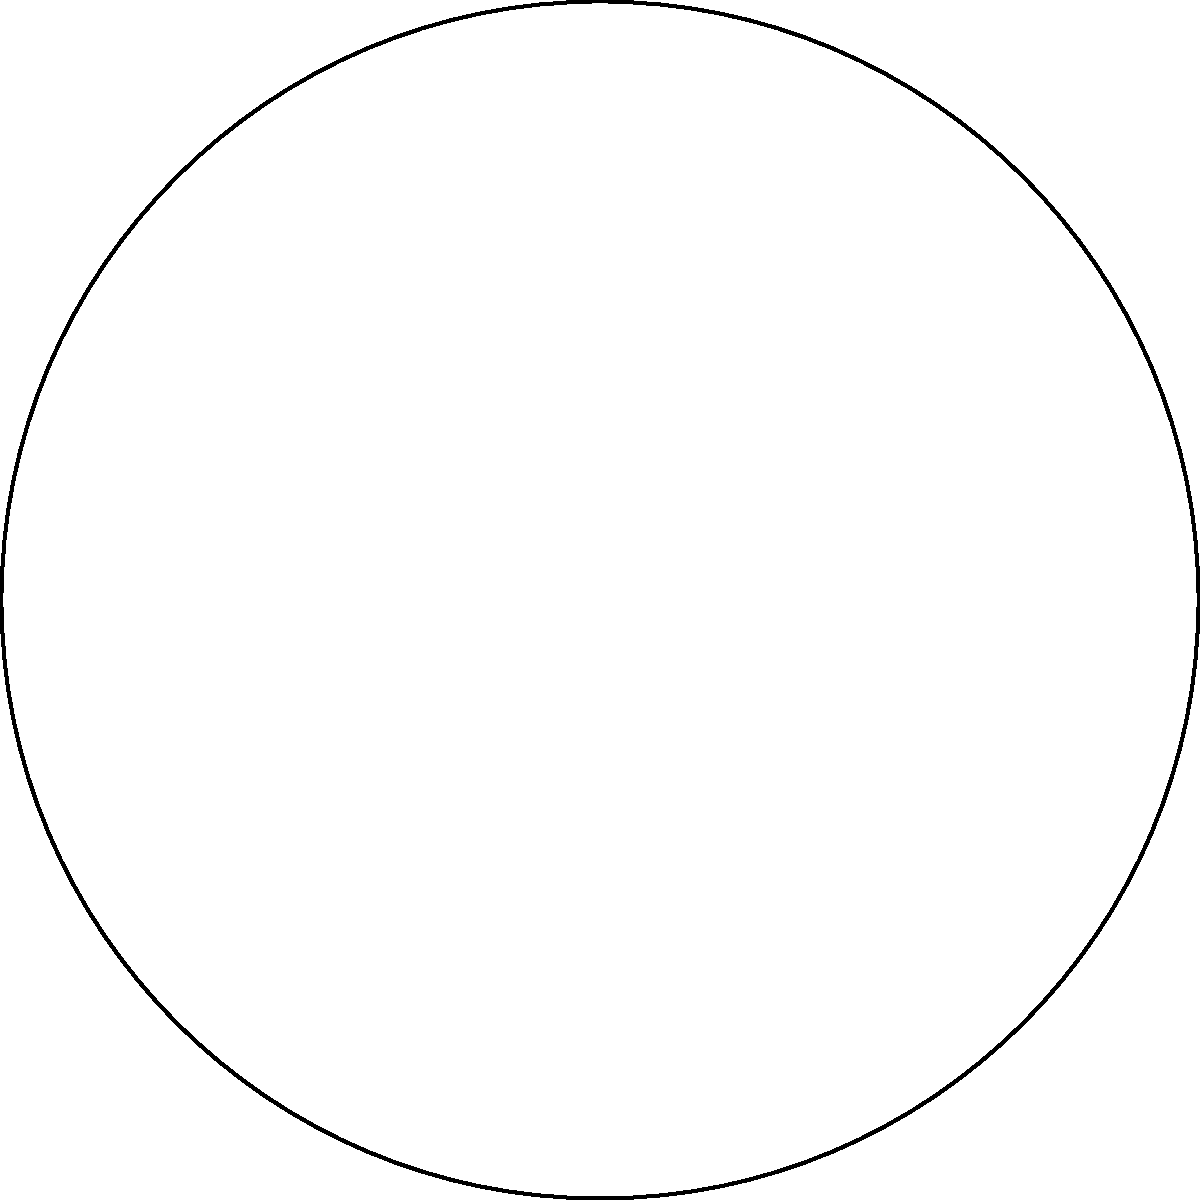In the hyperbolic plane model shown above, a regular pentagon $A_1A_2A_3A_4A_5$ is inscribed in the unit disk. If the hyperbolic distance between the center O and any vertex is $d$, what is the hyperbolic area of the pentagon in terms of $d$? To solve this problem, we'll follow these steps:

1) In hyperbolic geometry, the area of a regular n-gon is given by the formula:

   $A = (n-2)\pi - n\alpha$

   where $\alpha$ is the angle at each vertex.

2) For a pentagon, $n = 5$, so our formula becomes:

   $A = 3\pi - 5\alpha$

3) In a regular pentagon, each central angle (angle formed by two radii to adjacent vertices) is $\frac{2\pi}{5}$.

4) In hyperbolic geometry, the relation between the central angle $\theta$ and the vertex angle $\alpha$ in a regular polygon is:

   $\cos(\frac{\alpha}{2}) = \frac{\cosh(d)}{\sinh(d)} \sin(\frac{\theta}{2})$

5) Substituting $\theta = \frac{2\pi}{5}$:

   $\cos(\frac{\alpha}{2}) = \frac{\cosh(d)}{\sinh(d)} \sin(\frac{\pi}{5})$

6) We can simplify this using the hyperbolic tangent function:

   $\cos(\frac{\alpha}{2}) = \frac{1}{\tanh(d)} \sin(\frac{\pi}{5})$

7) Therefore:

   $\alpha = 2 \arccos(\frac{1}{\tanh(d)} \sin(\frac{\pi}{5}))$

8) Substituting this back into our area formula:

   $A = 3\pi - 10 \arccos(\frac{1}{\tanh(d)} \sin(\frac{\pi}{5}))$

This gives us the area of the hyperbolic pentagon in terms of $d$.
Answer: $3\pi - 10 \arccos(\frac{1}{\tanh(d)} \sin(\frac{\pi}{5}))$ 